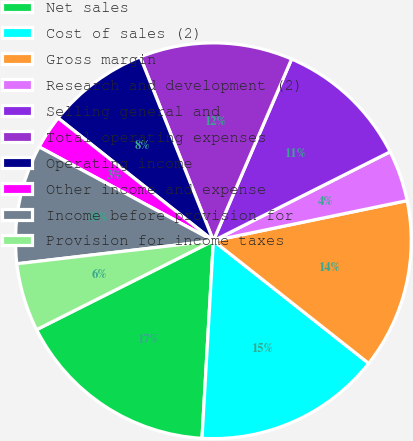<chart> <loc_0><loc_0><loc_500><loc_500><pie_chart><fcel>Net sales<fcel>Cost of sales (2)<fcel>Gross margin<fcel>Research and development (2)<fcel>Selling general and<fcel>Total operating expenses<fcel>Operating income<fcel>Other income and expense<fcel>Income before provision for<fcel>Provision for income taxes<nl><fcel>16.67%<fcel>15.28%<fcel>13.89%<fcel>4.17%<fcel>11.11%<fcel>12.5%<fcel>8.33%<fcel>2.78%<fcel>9.72%<fcel>5.56%<nl></chart> 